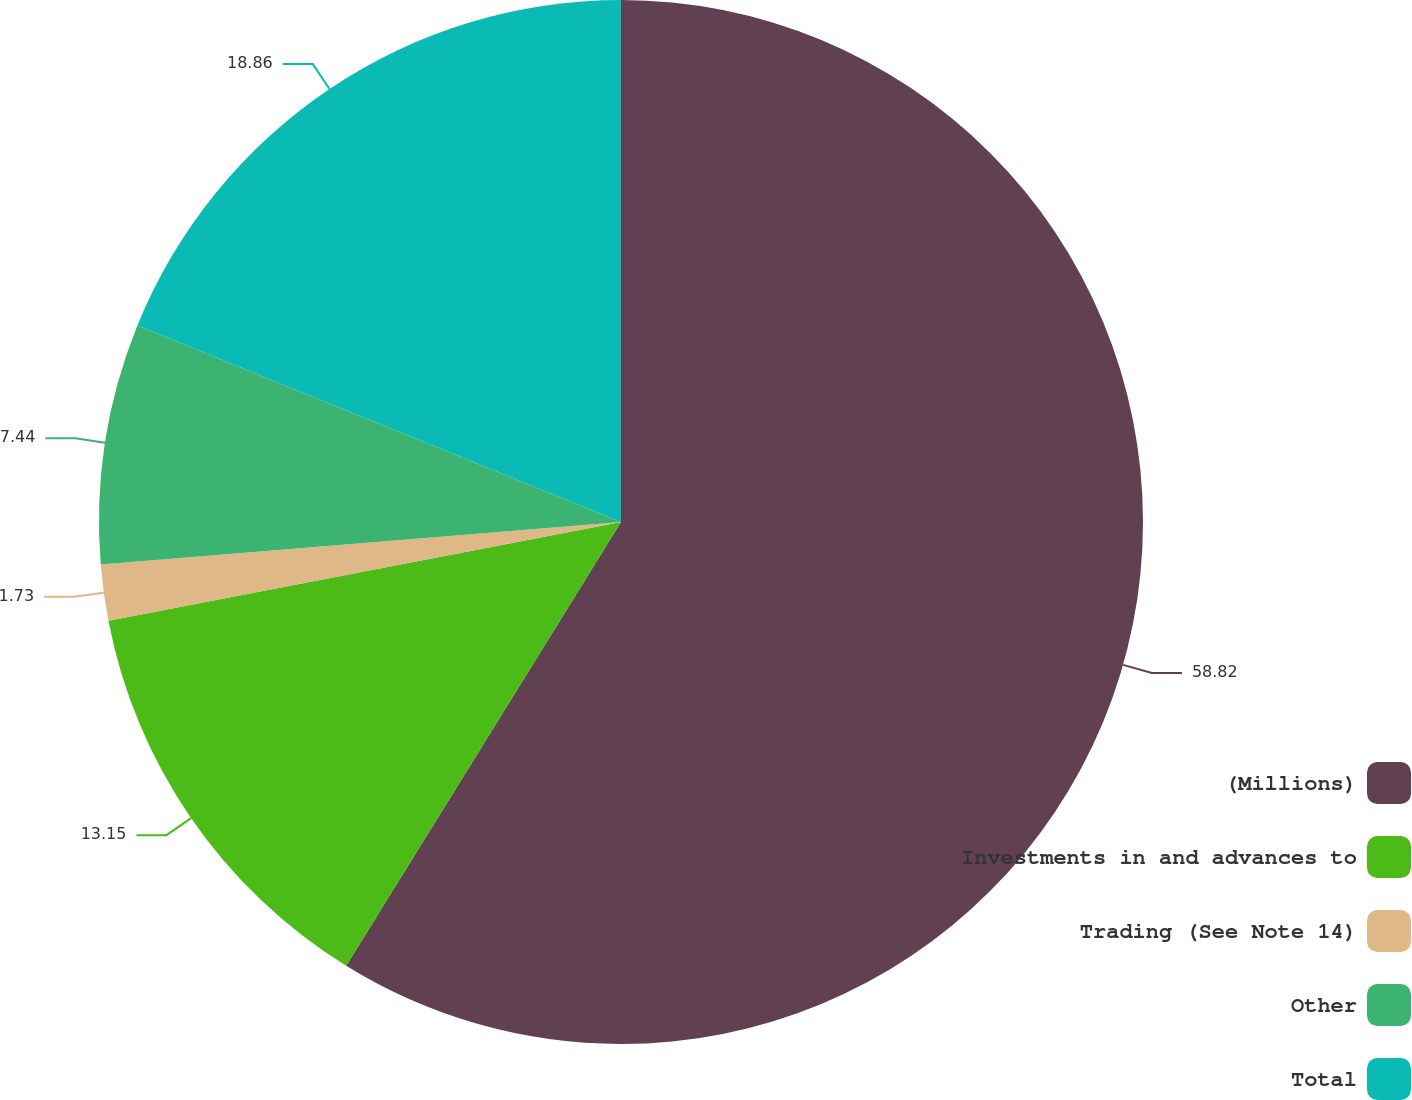Convert chart to OTSL. <chart><loc_0><loc_0><loc_500><loc_500><pie_chart><fcel>(Millions)<fcel>Investments in and advances to<fcel>Trading (See Note 14)<fcel>Other<fcel>Total<nl><fcel>58.83%<fcel>13.15%<fcel>1.73%<fcel>7.44%<fcel>18.86%<nl></chart> 